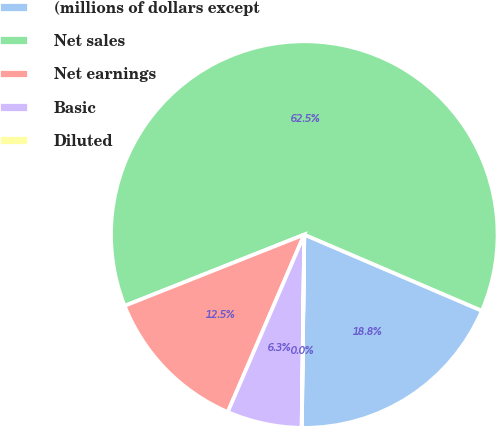Convert chart. <chart><loc_0><loc_0><loc_500><loc_500><pie_chart><fcel>(millions of dollars except<fcel>Net sales<fcel>Net earnings<fcel>Basic<fcel>Diluted<nl><fcel>18.75%<fcel>62.46%<fcel>12.51%<fcel>6.26%<fcel>0.02%<nl></chart> 